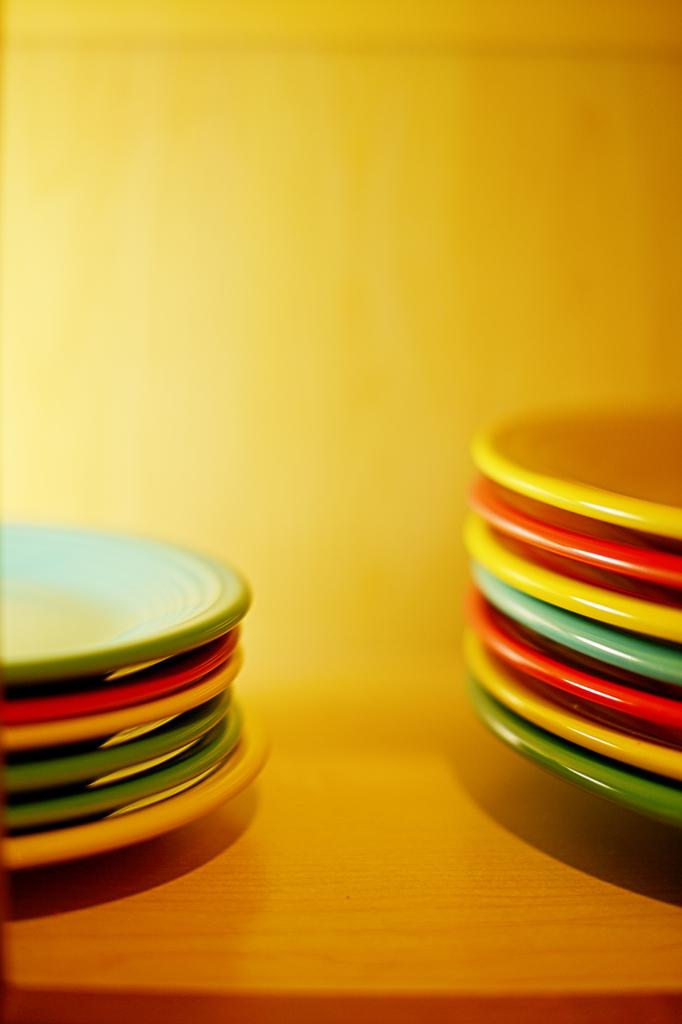What objects can be seen in the image? There are plates in the image. Where are the plates located? The plates are on a wooden surface. What else can be seen in the image besides the plates? There is a wall visible in the image. What color is the paint on the top of the wall in the image? There is: There is no mention of paint or the top of the wall in the provided facts, so we cannot determine the color of the paint from the information given. 